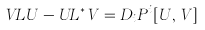<formula> <loc_0><loc_0><loc_500><loc_500>V L U - U L ^ { \ast } V = D _ { i } P ^ { i } [ U , V ]</formula> 